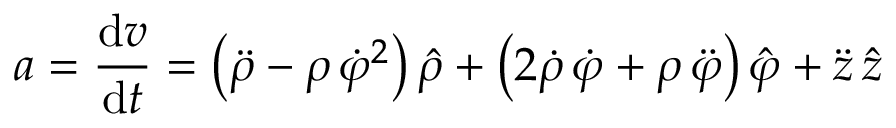Convert formula to latex. <formula><loc_0><loc_0><loc_500><loc_500>{ a } = { \frac { d { v } } { d t } } = \left ( { \ddot { \rho } } - \rho \, { \dot { \varphi } } ^ { 2 } \right ) { \hat { \rho } } + \left ( 2 { \dot { \rho } } \, { \dot { \varphi } } + \rho \, { \ddot { \varphi } } \right ) { \hat { \varphi } } + { \ddot { z } } \, { \hat { z } }</formula> 